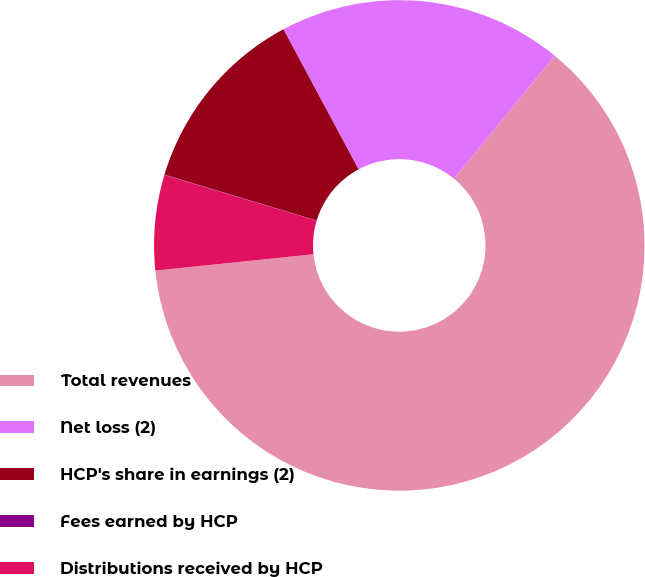Convert chart to OTSL. <chart><loc_0><loc_0><loc_500><loc_500><pie_chart><fcel>Total revenues<fcel>Net loss (2)<fcel>HCP's share in earnings (2)<fcel>Fees earned by HCP<fcel>Distributions received by HCP<nl><fcel>62.44%<fcel>18.75%<fcel>12.51%<fcel>0.03%<fcel>6.27%<nl></chart> 